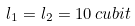Convert formula to latex. <formula><loc_0><loc_0><loc_500><loc_500>l _ { 1 } = l _ { 2 } = 1 0 \, c u b i t</formula> 